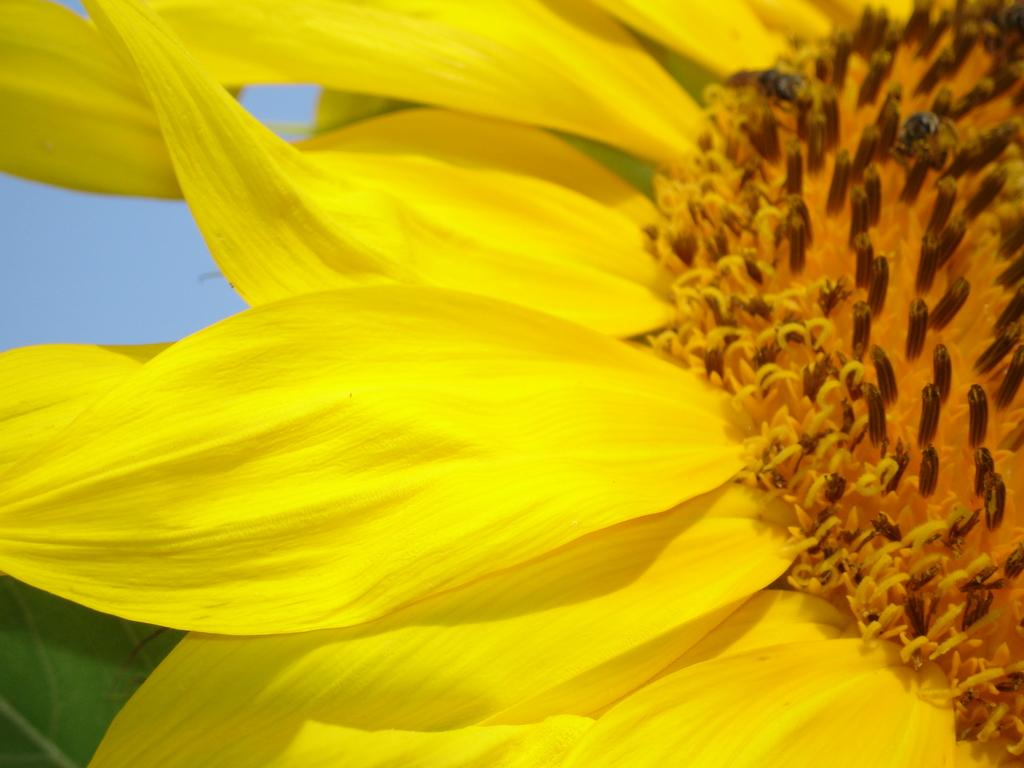What is the main subject of the image? There is a flower in the image. What color is the flower? The flower is yellow. What else can be seen in the background of the image? There is a leaf and the sky visible in the background of the image. What type of doll is sitting under the shade of the flower in the image? There is no doll present in the image; it only features a yellow flower and a leaf in the background. 